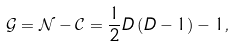Convert formula to latex. <formula><loc_0><loc_0><loc_500><loc_500>\mathcal { G } = \mathcal { N } - \mathcal { C } = \frac { 1 } { 2 } D \left ( D - 1 \right ) - 1 ,</formula> 